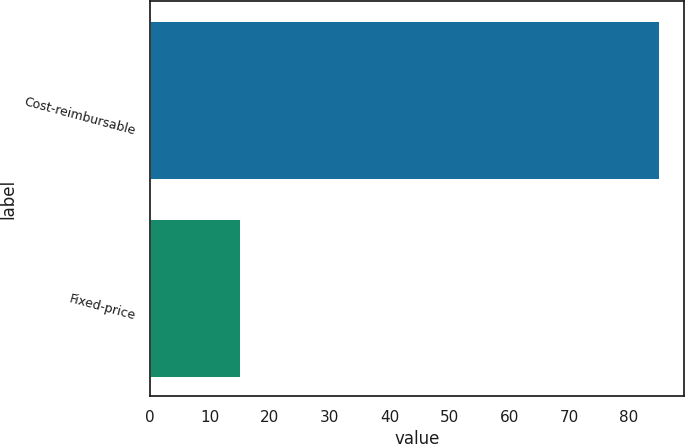Convert chart. <chart><loc_0><loc_0><loc_500><loc_500><bar_chart><fcel>Cost-reimbursable<fcel>Fixed-price<nl><fcel>85<fcel>15<nl></chart> 